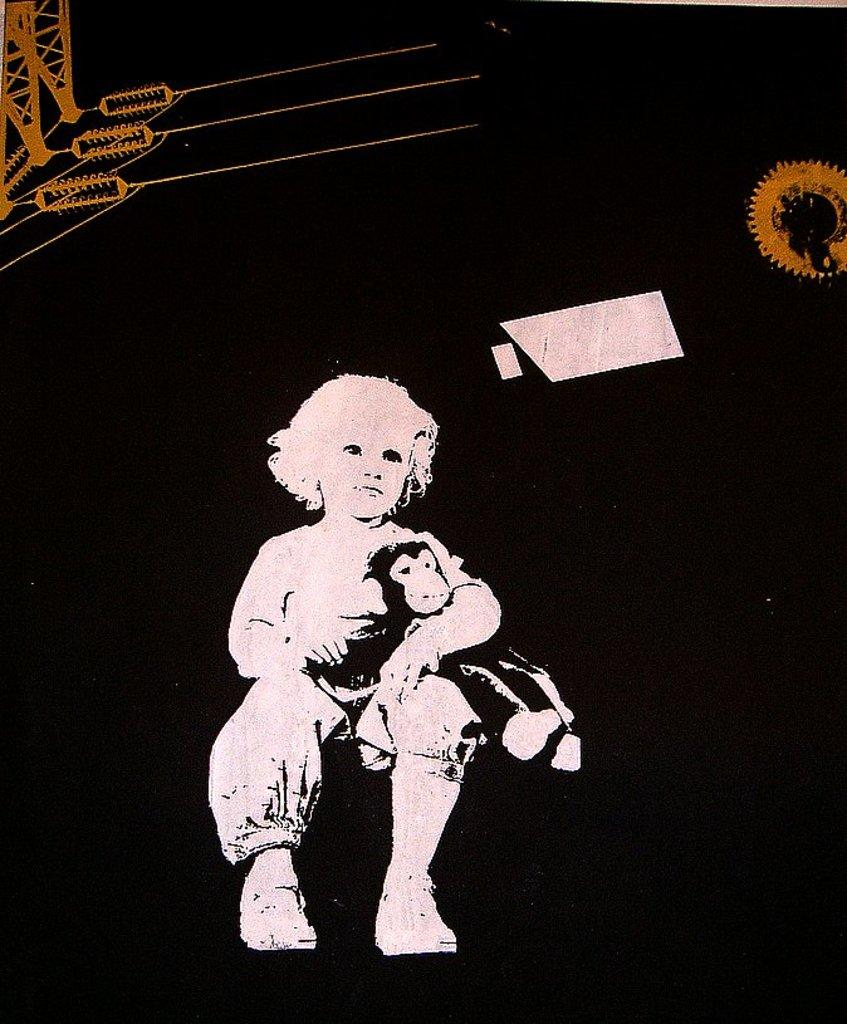What is the main subject of the image? The main subject of the image is an illustration of a kid. What is the kid holding in the image? The kid is holding a toy in the image. How would you describe the background of the image? The background of the image is dark. What type of support can be seen in the image? There is no support visible in the image; it features an illustration of a kid holding a toy against a dark background. What word is written on the toy the kid is holding? There is no word visible on the toy the kid is holding in the image. 